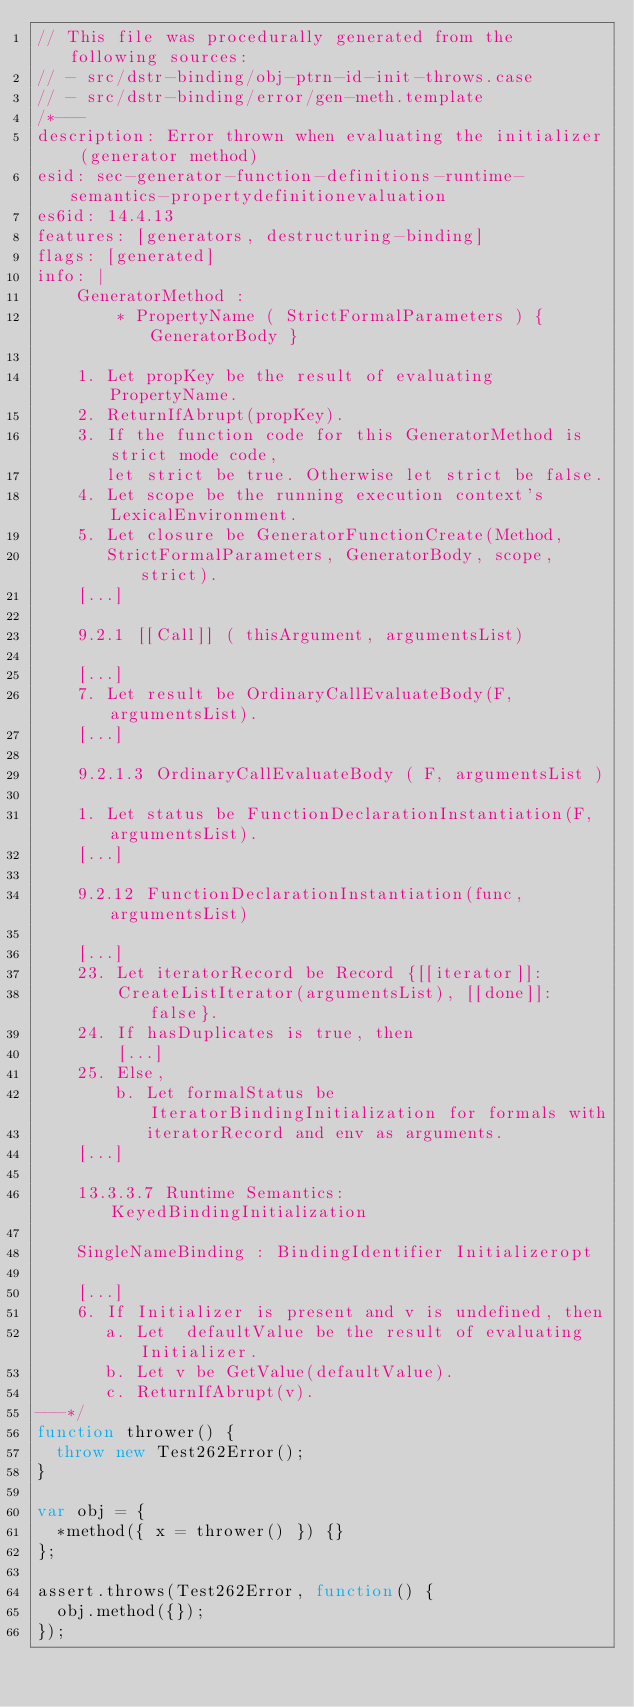Convert code to text. <code><loc_0><loc_0><loc_500><loc_500><_JavaScript_>// This file was procedurally generated from the following sources:
// - src/dstr-binding/obj-ptrn-id-init-throws.case
// - src/dstr-binding/error/gen-meth.template
/*---
description: Error thrown when evaluating the initializer (generator method)
esid: sec-generator-function-definitions-runtime-semantics-propertydefinitionevaluation
es6id: 14.4.13
features: [generators, destructuring-binding]
flags: [generated]
info: |
    GeneratorMethod :
        * PropertyName ( StrictFormalParameters ) { GeneratorBody }

    1. Let propKey be the result of evaluating PropertyName.
    2. ReturnIfAbrupt(propKey).
    3. If the function code for this GeneratorMethod is strict mode code,
       let strict be true. Otherwise let strict be false.
    4. Let scope be the running execution context's LexicalEnvironment.
    5. Let closure be GeneratorFunctionCreate(Method,
       StrictFormalParameters, GeneratorBody, scope, strict).
    [...]

    9.2.1 [[Call]] ( thisArgument, argumentsList)

    [...]
    7. Let result be OrdinaryCallEvaluateBody(F, argumentsList).
    [...]

    9.2.1.3 OrdinaryCallEvaluateBody ( F, argumentsList )

    1. Let status be FunctionDeclarationInstantiation(F, argumentsList).
    [...]

    9.2.12 FunctionDeclarationInstantiation(func, argumentsList)

    [...]
    23. Let iteratorRecord be Record {[[iterator]]:
        CreateListIterator(argumentsList), [[done]]: false}.
    24. If hasDuplicates is true, then
        [...]
    25. Else,
        b. Let formalStatus be IteratorBindingInitialization for formals with
           iteratorRecord and env as arguments.
    [...]

    13.3.3.7 Runtime Semantics: KeyedBindingInitialization

    SingleNameBinding : BindingIdentifier Initializeropt

    [...]
    6. If Initializer is present and v is undefined, then
       a. Let  defaultValue be the result of evaluating Initializer.
       b. Let v be GetValue(defaultValue).
       c. ReturnIfAbrupt(v).
---*/
function thrower() {
  throw new Test262Error();
}

var obj = {
  *method({ x = thrower() }) {}
};

assert.throws(Test262Error, function() {
  obj.method({});
});
</code> 